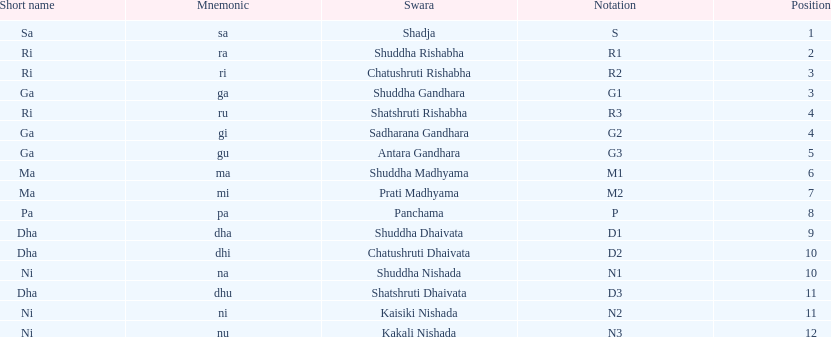What is the overall count of positions mentioned? 16. Write the full table. {'header': ['Short name', 'Mnemonic', 'Swara', 'Notation', 'Position'], 'rows': [['Sa', 'sa', 'Shadja', 'S', '1'], ['Ri', 'ra', 'Shuddha Rishabha', 'R1', '2'], ['Ri', 'ri', 'Chatushruti Rishabha', 'R2', '3'], ['Ga', 'ga', 'Shuddha Gandhara', 'G1', '3'], ['Ri', 'ru', 'Shatshruti Rishabha', 'R3', '4'], ['Ga', 'gi', 'Sadharana Gandhara', 'G2', '4'], ['Ga', 'gu', 'Antara Gandhara', 'G3', '5'], ['Ma', 'ma', 'Shuddha Madhyama', 'M1', '6'], ['Ma', 'mi', 'Prati Madhyama', 'M2', '7'], ['Pa', 'pa', 'Panchama', 'P', '8'], ['Dha', 'dha', 'Shuddha Dhaivata', 'D1', '9'], ['Dha', 'dhi', 'Chatushruti Dhaivata', 'D2', '10'], ['Ni', 'na', 'Shuddha Nishada', 'N1', '10'], ['Dha', 'dhu', 'Shatshruti Dhaivata', 'D3', '11'], ['Ni', 'ni', 'Kaisiki Nishada', 'N2', '11'], ['Ni', 'nu', 'Kakali Nishada', 'N3', '12']]} 